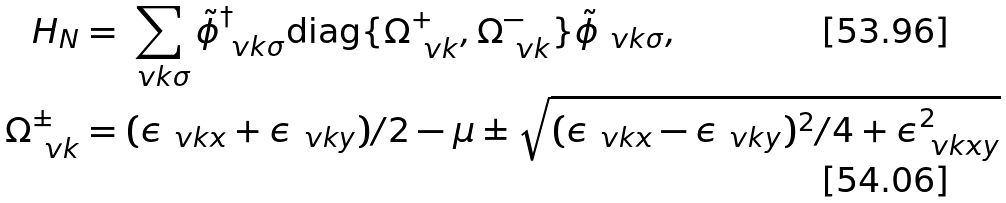<formula> <loc_0><loc_0><loc_500><loc_500>H _ { N } & = \sum _ { \ v k \sigma } \tilde { \phi } _ { \ v k \sigma } ^ { \dag } \text {diag} \{ \Omega _ { \ v k } ^ { + } , \Omega _ { \ v k } ^ { - } \} \tilde { \phi } _ { \ v k \sigma } , \\ \Omega _ { \ v k } ^ { \pm } & = ( \epsilon _ { \ v k x } + \epsilon _ { \ v k y } ) / 2 - \mu \pm \sqrt { ( \epsilon _ { \ v k x } - \epsilon _ { \ v k y } ) ^ { 2 } / 4 + \epsilon _ { \ v k x y } ^ { 2 } }</formula> 